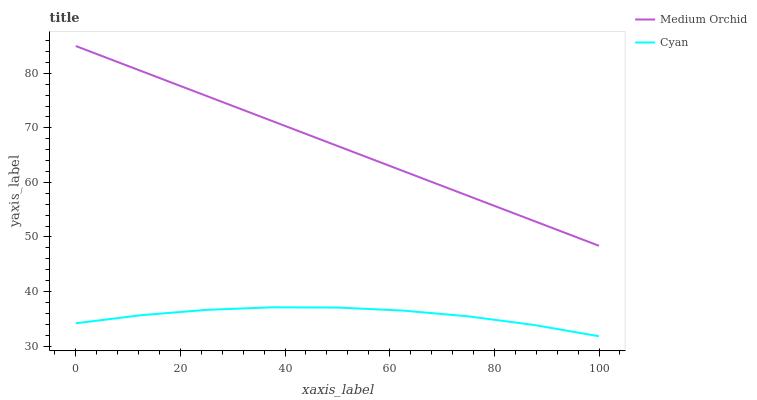Does Cyan have the minimum area under the curve?
Answer yes or no. Yes. Does Medium Orchid have the maximum area under the curve?
Answer yes or no. Yes. Does Medium Orchid have the minimum area under the curve?
Answer yes or no. No. Is Medium Orchid the smoothest?
Answer yes or no. Yes. Is Cyan the roughest?
Answer yes or no. Yes. Is Medium Orchid the roughest?
Answer yes or no. No. Does Cyan have the lowest value?
Answer yes or no. Yes. Does Medium Orchid have the lowest value?
Answer yes or no. No. Does Medium Orchid have the highest value?
Answer yes or no. Yes. Is Cyan less than Medium Orchid?
Answer yes or no. Yes. Is Medium Orchid greater than Cyan?
Answer yes or no. Yes. Does Cyan intersect Medium Orchid?
Answer yes or no. No. 